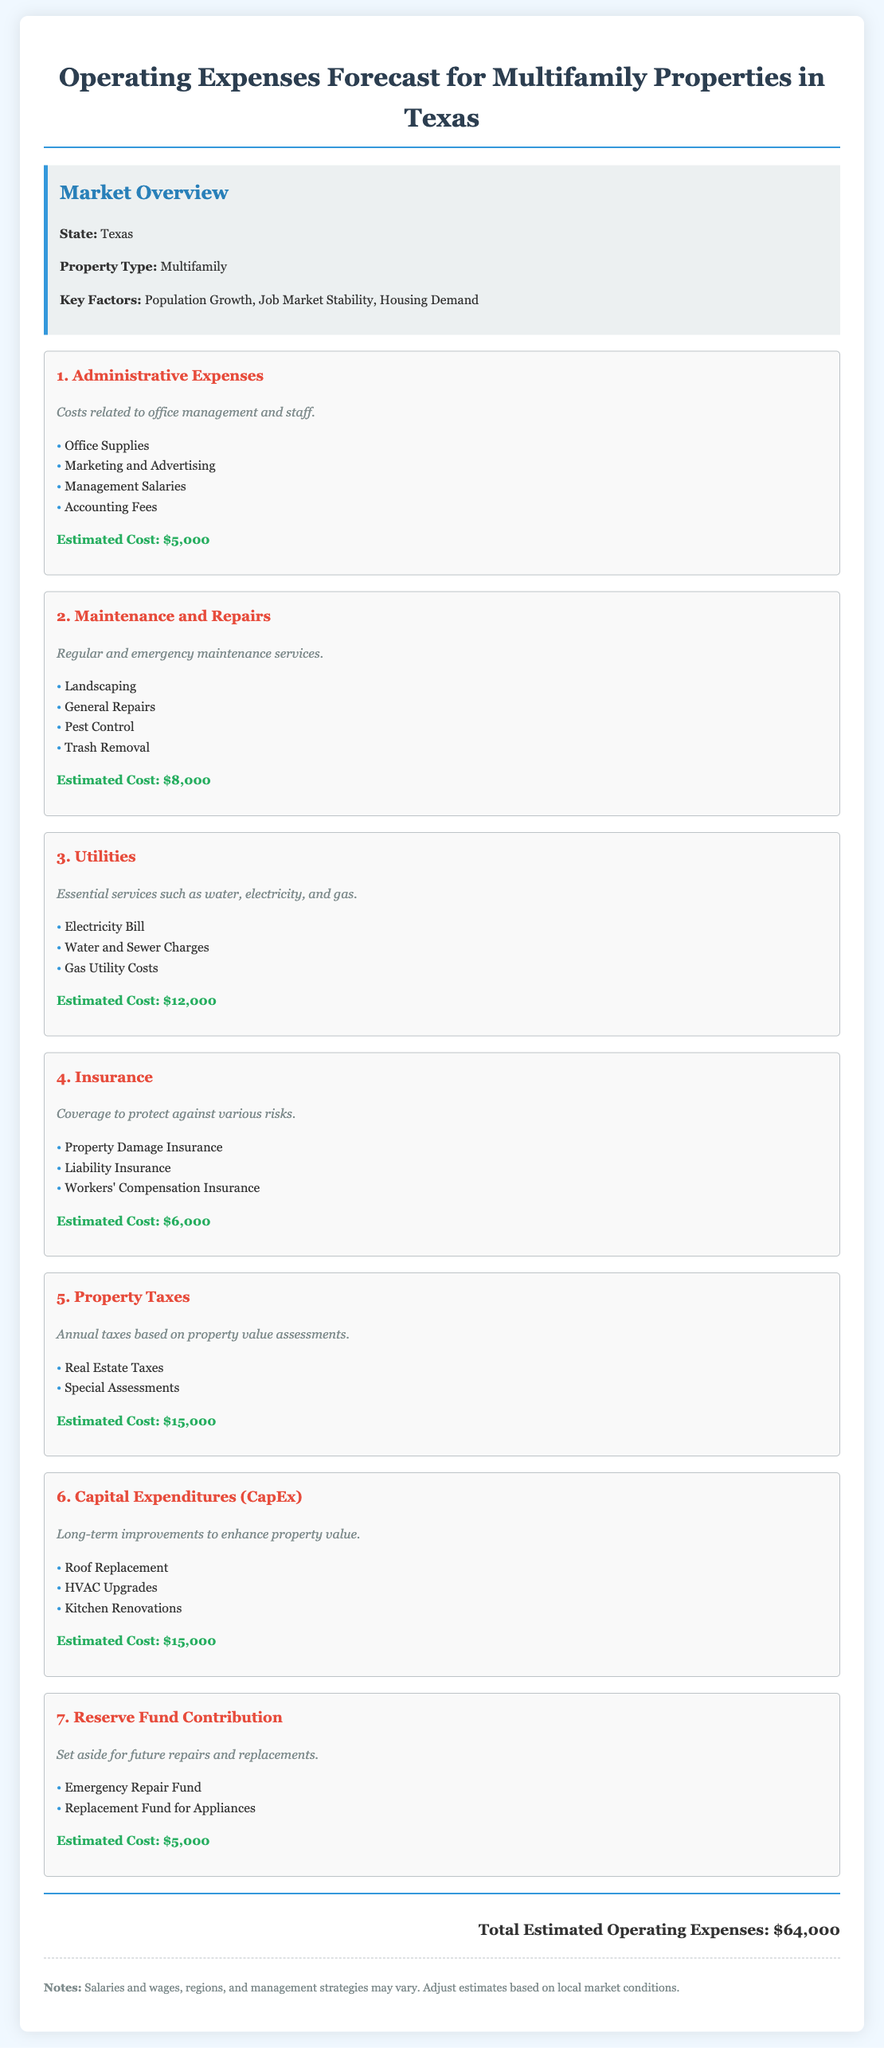what is the estimated cost for Administrative Expenses? The estimated cost for Administrative Expenses is listed specifically as $5,000.
Answer: $5,000 what are the examples of Maintenance and Repairs costs? The document lists specific examples such as Landscaping, General Repairs, Pest Control, and Trash Removal under Maintenance and Repairs.
Answer: Landscaping, General Repairs, Pest Control, Trash Removal how much is allocated for Utilities? The estimated cost allocated for Utilities is explicitly mentioned as $12,000.
Answer: $12,000 what is the total estimated operating expenses? The total estimated operating expenses are calculated as the sum of all individual estimated costs, which totals $64,000.
Answer: $64,000 which expense category has the highest estimated cost? Among the various expense categories, Property Taxes has the highest estimated cost listed at $15,000.
Answer: Property Taxes how much should be contributed to the Reserve Fund? The document specifies that the contribution to the Reserve Fund is set at $5,000.
Answer: $5,000 what are the key factors impacting the Texas multifamily market? The key factors affecting the Texas multifamily market mentioned in the document are Population Growth, Job Market Stability, and Housing Demand.
Answer: Population Growth, Job Market Stability, Housing Demand what type of insurance is included in the budget? The budget includes several types of insurance, specifically Property Damage Insurance, Liability Insurance, and Workers' Compensation Insurance.
Answer: Property Damage Insurance, Liability Insurance, Workers' Compensation Insurance what is the estimated cost for Capital Expenditures? The estimated cost for Capital Expenditures (CapEx) is detailed in the document as $15,000.
Answer: $15,000 